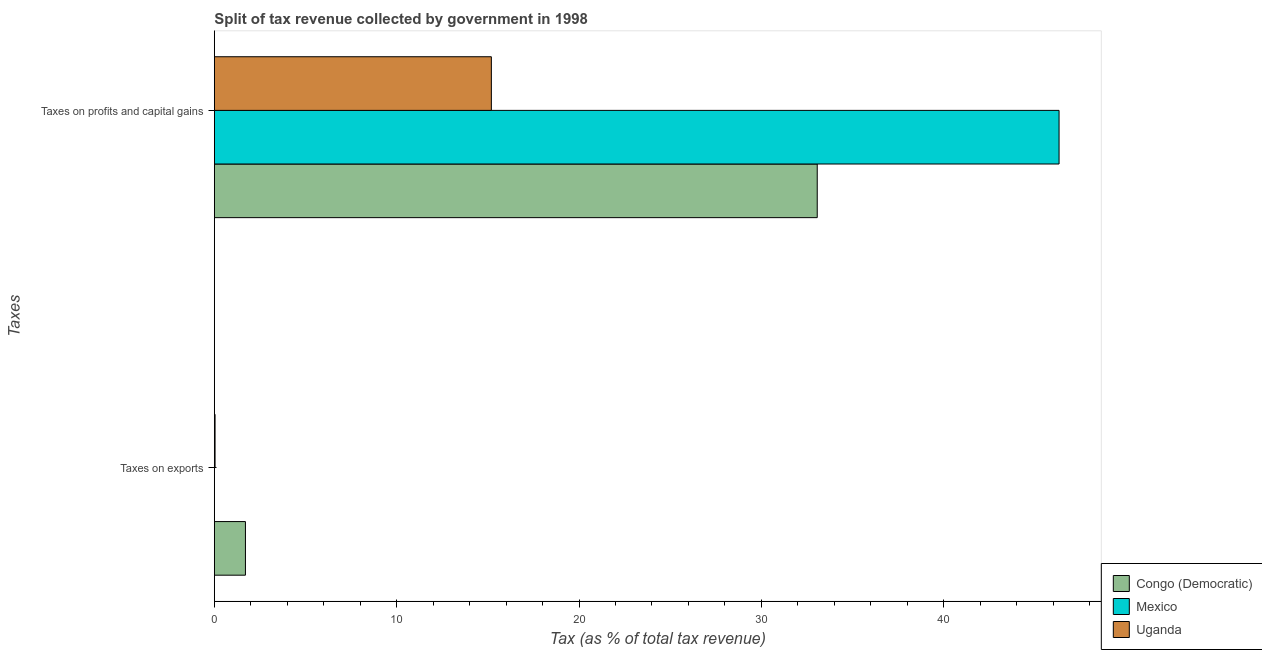How many groups of bars are there?
Ensure brevity in your answer.  2. How many bars are there on the 2nd tick from the top?
Your response must be concise. 3. What is the label of the 1st group of bars from the top?
Your answer should be very brief. Taxes on profits and capital gains. What is the percentage of revenue obtained from taxes on exports in Congo (Democratic)?
Ensure brevity in your answer.  1.7. Across all countries, what is the maximum percentage of revenue obtained from taxes on exports?
Give a very brief answer. 1.7. Across all countries, what is the minimum percentage of revenue obtained from taxes on profits and capital gains?
Provide a short and direct response. 15.19. In which country was the percentage of revenue obtained from taxes on exports minimum?
Keep it short and to the point. Mexico. What is the total percentage of revenue obtained from taxes on exports in the graph?
Make the answer very short. 1.74. What is the difference between the percentage of revenue obtained from taxes on exports in Uganda and that in Mexico?
Offer a very short reply. 0.04. What is the difference between the percentage of revenue obtained from taxes on exports in Congo (Democratic) and the percentage of revenue obtained from taxes on profits and capital gains in Uganda?
Keep it short and to the point. -13.49. What is the average percentage of revenue obtained from taxes on profits and capital gains per country?
Keep it short and to the point. 31.53. What is the difference between the percentage of revenue obtained from taxes on exports and percentage of revenue obtained from taxes on profits and capital gains in Uganda?
Provide a short and direct response. -15.15. In how many countries, is the percentage of revenue obtained from taxes on profits and capital gains greater than 8 %?
Provide a short and direct response. 3. What is the ratio of the percentage of revenue obtained from taxes on exports in Mexico to that in Uganda?
Give a very brief answer. 0.01. Is the percentage of revenue obtained from taxes on profits and capital gains in Congo (Democratic) less than that in Mexico?
Give a very brief answer. Yes. In how many countries, is the percentage of revenue obtained from taxes on profits and capital gains greater than the average percentage of revenue obtained from taxes on profits and capital gains taken over all countries?
Make the answer very short. 2. What does the 3rd bar from the bottom in Taxes on exports represents?
Offer a very short reply. Uganda. How many bars are there?
Make the answer very short. 6. How many countries are there in the graph?
Give a very brief answer. 3. What is the difference between two consecutive major ticks on the X-axis?
Keep it short and to the point. 10. Are the values on the major ticks of X-axis written in scientific E-notation?
Keep it short and to the point. No. Does the graph contain any zero values?
Offer a very short reply. No. Does the graph contain grids?
Your answer should be very brief. No. How are the legend labels stacked?
Your answer should be very brief. Vertical. What is the title of the graph?
Your response must be concise. Split of tax revenue collected by government in 1998. Does "Korea (Democratic)" appear as one of the legend labels in the graph?
Your answer should be compact. No. What is the label or title of the X-axis?
Give a very brief answer. Tax (as % of total tax revenue). What is the label or title of the Y-axis?
Provide a short and direct response. Taxes. What is the Tax (as % of total tax revenue) in Congo (Democratic) in Taxes on exports?
Your answer should be compact. 1.7. What is the Tax (as % of total tax revenue) of Mexico in Taxes on exports?
Provide a succinct answer. 0. What is the Tax (as % of total tax revenue) in Uganda in Taxes on exports?
Offer a terse response. 0.04. What is the Tax (as % of total tax revenue) in Congo (Democratic) in Taxes on profits and capital gains?
Offer a very short reply. 33.07. What is the Tax (as % of total tax revenue) of Mexico in Taxes on profits and capital gains?
Give a very brief answer. 46.33. What is the Tax (as % of total tax revenue) in Uganda in Taxes on profits and capital gains?
Your answer should be compact. 15.19. Across all Taxes, what is the maximum Tax (as % of total tax revenue) of Congo (Democratic)?
Ensure brevity in your answer.  33.07. Across all Taxes, what is the maximum Tax (as % of total tax revenue) of Mexico?
Your answer should be compact. 46.33. Across all Taxes, what is the maximum Tax (as % of total tax revenue) of Uganda?
Offer a very short reply. 15.19. Across all Taxes, what is the minimum Tax (as % of total tax revenue) in Congo (Democratic)?
Give a very brief answer. 1.7. Across all Taxes, what is the minimum Tax (as % of total tax revenue) of Mexico?
Make the answer very short. 0. Across all Taxes, what is the minimum Tax (as % of total tax revenue) in Uganda?
Offer a terse response. 0.04. What is the total Tax (as % of total tax revenue) in Congo (Democratic) in the graph?
Offer a terse response. 34.77. What is the total Tax (as % of total tax revenue) in Mexico in the graph?
Offer a terse response. 46.33. What is the total Tax (as % of total tax revenue) of Uganda in the graph?
Keep it short and to the point. 15.23. What is the difference between the Tax (as % of total tax revenue) of Congo (Democratic) in Taxes on exports and that in Taxes on profits and capital gains?
Provide a succinct answer. -31.36. What is the difference between the Tax (as % of total tax revenue) of Mexico in Taxes on exports and that in Taxes on profits and capital gains?
Provide a succinct answer. -46.33. What is the difference between the Tax (as % of total tax revenue) of Uganda in Taxes on exports and that in Taxes on profits and capital gains?
Your answer should be compact. -15.15. What is the difference between the Tax (as % of total tax revenue) in Congo (Democratic) in Taxes on exports and the Tax (as % of total tax revenue) in Mexico in Taxes on profits and capital gains?
Give a very brief answer. -44.62. What is the difference between the Tax (as % of total tax revenue) of Congo (Democratic) in Taxes on exports and the Tax (as % of total tax revenue) of Uganda in Taxes on profits and capital gains?
Keep it short and to the point. -13.49. What is the difference between the Tax (as % of total tax revenue) of Mexico in Taxes on exports and the Tax (as % of total tax revenue) of Uganda in Taxes on profits and capital gains?
Offer a terse response. -15.19. What is the average Tax (as % of total tax revenue) in Congo (Democratic) per Taxes?
Your answer should be very brief. 17.39. What is the average Tax (as % of total tax revenue) of Mexico per Taxes?
Ensure brevity in your answer.  23.16. What is the average Tax (as % of total tax revenue) in Uganda per Taxes?
Your answer should be very brief. 7.62. What is the difference between the Tax (as % of total tax revenue) of Congo (Democratic) and Tax (as % of total tax revenue) of Mexico in Taxes on exports?
Offer a terse response. 1.7. What is the difference between the Tax (as % of total tax revenue) of Congo (Democratic) and Tax (as % of total tax revenue) of Uganda in Taxes on exports?
Offer a terse response. 1.67. What is the difference between the Tax (as % of total tax revenue) of Mexico and Tax (as % of total tax revenue) of Uganda in Taxes on exports?
Your answer should be very brief. -0.04. What is the difference between the Tax (as % of total tax revenue) in Congo (Democratic) and Tax (as % of total tax revenue) in Mexico in Taxes on profits and capital gains?
Provide a short and direct response. -13.26. What is the difference between the Tax (as % of total tax revenue) in Congo (Democratic) and Tax (as % of total tax revenue) in Uganda in Taxes on profits and capital gains?
Make the answer very short. 17.87. What is the difference between the Tax (as % of total tax revenue) in Mexico and Tax (as % of total tax revenue) in Uganda in Taxes on profits and capital gains?
Your answer should be compact. 31.14. What is the ratio of the Tax (as % of total tax revenue) of Congo (Democratic) in Taxes on exports to that in Taxes on profits and capital gains?
Your answer should be compact. 0.05. What is the ratio of the Tax (as % of total tax revenue) of Mexico in Taxes on exports to that in Taxes on profits and capital gains?
Your answer should be compact. 0. What is the ratio of the Tax (as % of total tax revenue) of Uganda in Taxes on exports to that in Taxes on profits and capital gains?
Your answer should be very brief. 0. What is the difference between the highest and the second highest Tax (as % of total tax revenue) of Congo (Democratic)?
Your answer should be very brief. 31.36. What is the difference between the highest and the second highest Tax (as % of total tax revenue) in Mexico?
Make the answer very short. 46.33. What is the difference between the highest and the second highest Tax (as % of total tax revenue) of Uganda?
Your response must be concise. 15.15. What is the difference between the highest and the lowest Tax (as % of total tax revenue) of Congo (Democratic)?
Ensure brevity in your answer.  31.36. What is the difference between the highest and the lowest Tax (as % of total tax revenue) of Mexico?
Offer a very short reply. 46.33. What is the difference between the highest and the lowest Tax (as % of total tax revenue) of Uganda?
Ensure brevity in your answer.  15.15. 